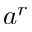<formula> <loc_0><loc_0><loc_500><loc_500>a ^ { r }</formula> 